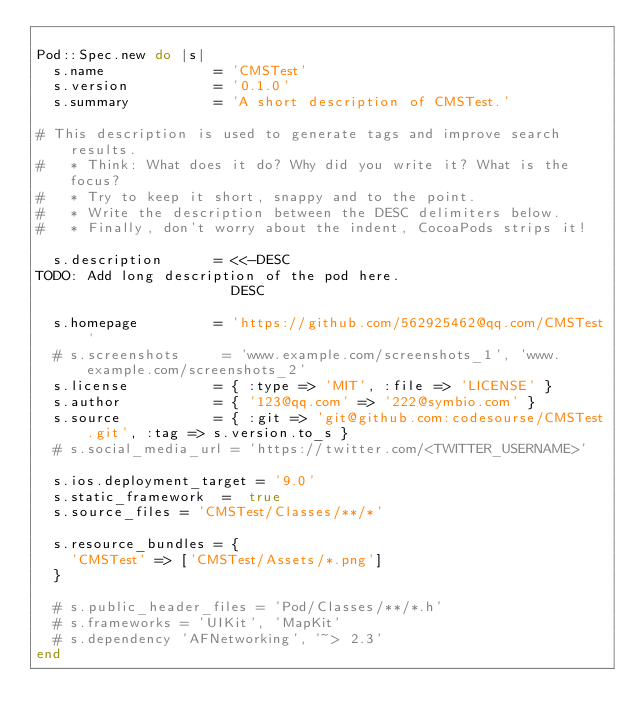Convert code to text. <code><loc_0><loc_0><loc_500><loc_500><_Ruby_>
Pod::Spec.new do |s|
  s.name             = 'CMSTest'
  s.version          = '0.1.0'
  s.summary          = 'A short description of CMSTest.'

# This description is used to generate tags and improve search results.
#   * Think: What does it do? Why did you write it? What is the focus?
#   * Try to keep it short, snappy and to the point.
#   * Write the description between the DESC delimiters below.
#   * Finally, don't worry about the indent, CocoaPods strips it!

  s.description      = <<-DESC
TODO: Add long description of the pod here.
                       DESC

  s.homepage         = 'https://github.com/562925462@qq.com/CMSTest'
  # s.screenshots     = 'www.example.com/screenshots_1', 'www.example.com/screenshots_2'
  s.license          = { :type => 'MIT', :file => 'LICENSE' }
  s.author           = { '123@qq.com' => '222@symbio.com' }
  s.source           = { :git => 'git@github.com:codesourse/CMSTest.git', :tag => s.version.to_s }
  # s.social_media_url = 'https://twitter.com/<TWITTER_USERNAME>'

  s.ios.deployment_target = '9.0'
  s.static_framework  =  true
  s.source_files = 'CMSTest/Classes/**/*'
  
  s.resource_bundles = {
    'CMSTest' => ['CMSTest/Assets/*.png']
  }

  # s.public_header_files = 'Pod/Classes/**/*.h'
  # s.frameworks = 'UIKit', 'MapKit'
  # s.dependency 'AFNetworking', '~> 2.3'
end
</code> 